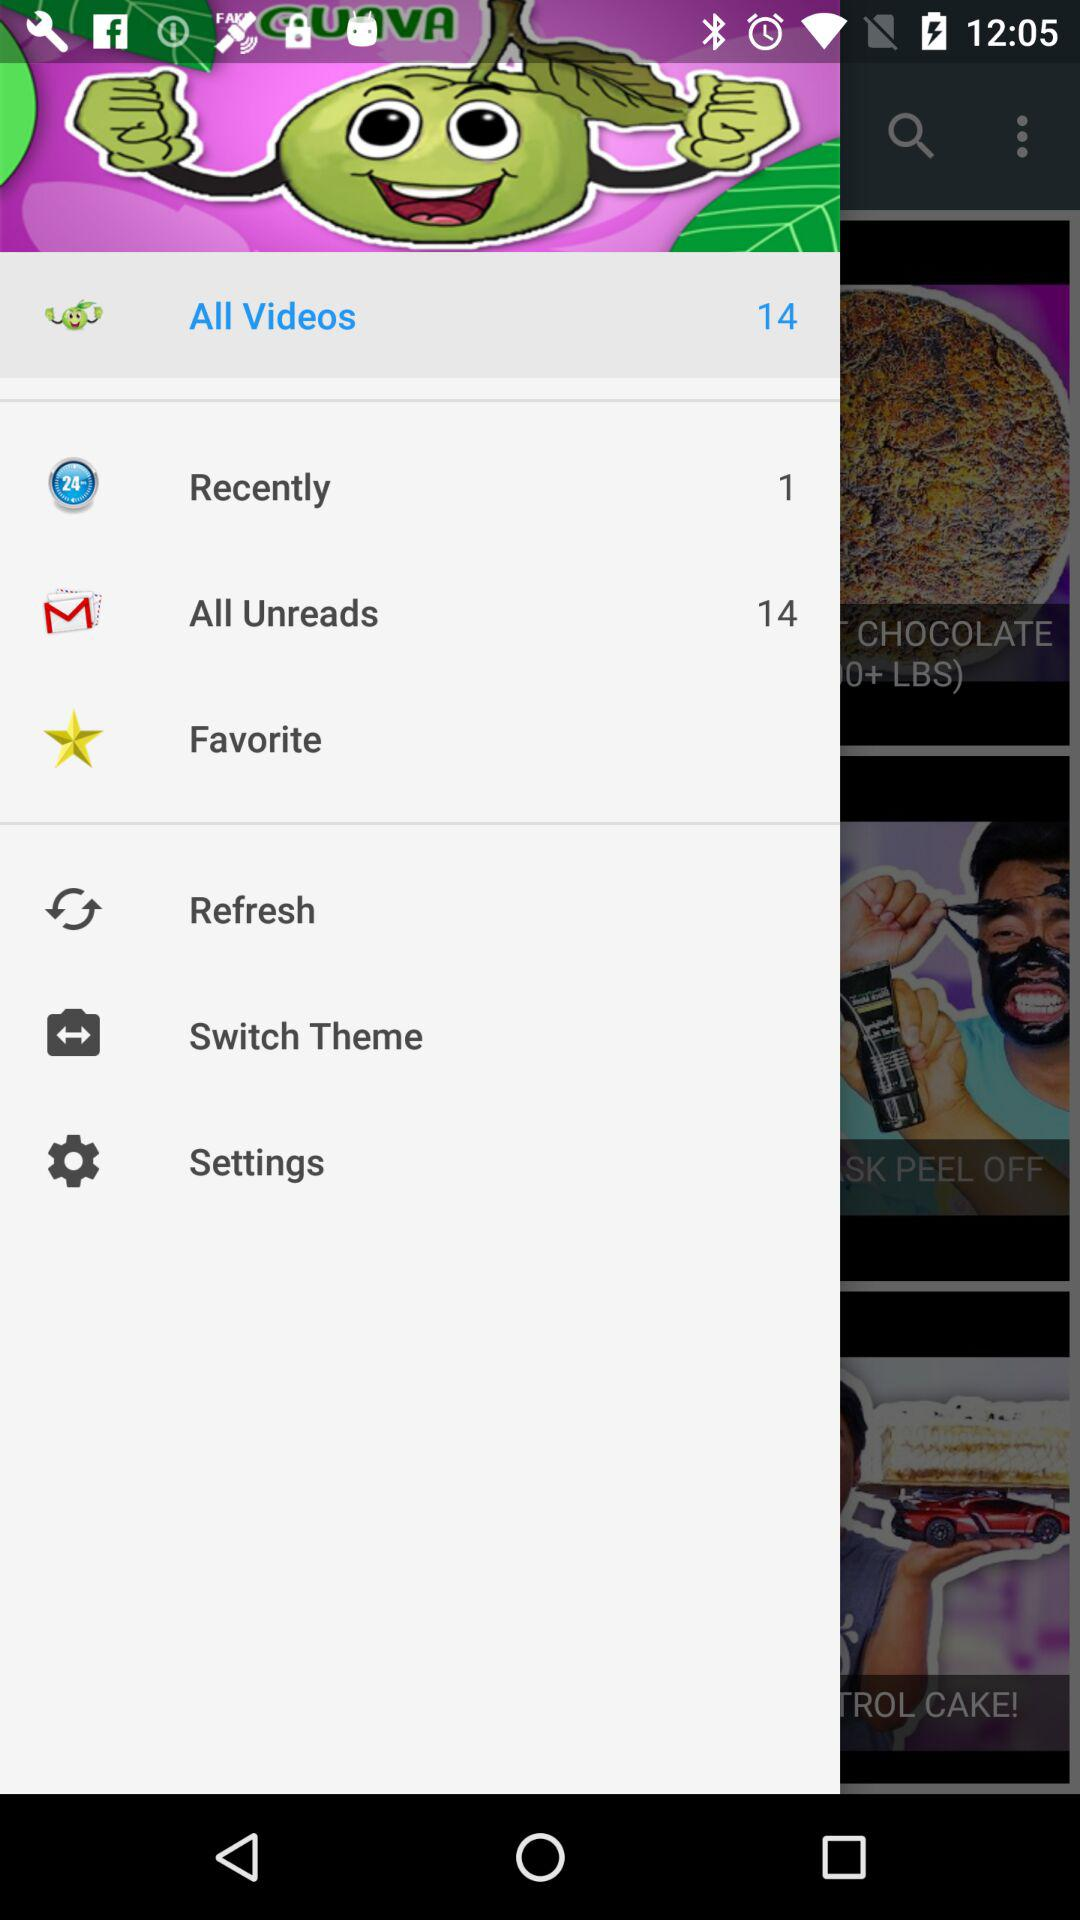How many videos in total are there? There are 14 videos. 